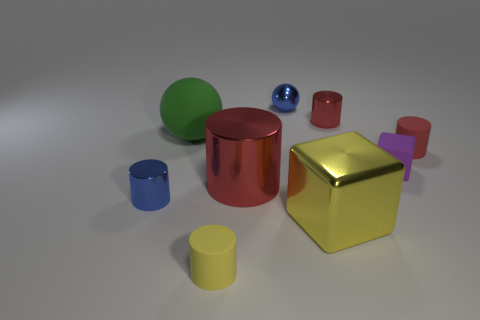Is there another green rubber thing that has the same size as the green matte object?
Give a very brief answer. No. There is a red shiny object that is the same size as the yellow cylinder; what is its shape?
Ensure brevity in your answer.  Cylinder. Are there any matte objects of the same shape as the big yellow metallic thing?
Keep it short and to the point. Yes. Does the tiny purple block have the same material as the cylinder behind the large sphere?
Ensure brevity in your answer.  No. Are there any small cylinders that have the same color as the metal ball?
Ensure brevity in your answer.  Yes. How many other objects are the same material as the green thing?
Your answer should be very brief. 3. There is a metallic ball; is it the same color as the rubber object that is in front of the metal cube?
Offer a terse response. No. Are there more rubber objects that are behind the small purple matte object than small red metallic objects?
Ensure brevity in your answer.  Yes. There is a small blue metallic thing that is in front of the tiny red thing right of the purple matte object; what number of small metal things are behind it?
Give a very brief answer. 2. Does the small blue object to the right of the big rubber object have the same shape as the large red shiny object?
Provide a succinct answer. No. 